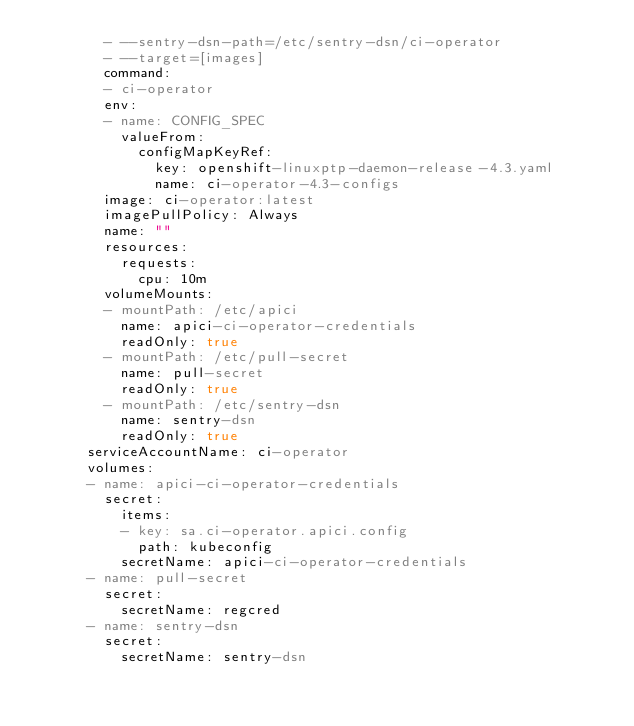<code> <loc_0><loc_0><loc_500><loc_500><_YAML_>        - --sentry-dsn-path=/etc/sentry-dsn/ci-operator
        - --target=[images]
        command:
        - ci-operator
        env:
        - name: CONFIG_SPEC
          valueFrom:
            configMapKeyRef:
              key: openshift-linuxptp-daemon-release-4.3.yaml
              name: ci-operator-4.3-configs
        image: ci-operator:latest
        imagePullPolicy: Always
        name: ""
        resources:
          requests:
            cpu: 10m
        volumeMounts:
        - mountPath: /etc/apici
          name: apici-ci-operator-credentials
          readOnly: true
        - mountPath: /etc/pull-secret
          name: pull-secret
          readOnly: true
        - mountPath: /etc/sentry-dsn
          name: sentry-dsn
          readOnly: true
      serviceAccountName: ci-operator
      volumes:
      - name: apici-ci-operator-credentials
        secret:
          items:
          - key: sa.ci-operator.apici.config
            path: kubeconfig
          secretName: apici-ci-operator-credentials
      - name: pull-secret
        secret:
          secretName: regcred
      - name: sentry-dsn
        secret:
          secretName: sentry-dsn
</code> 